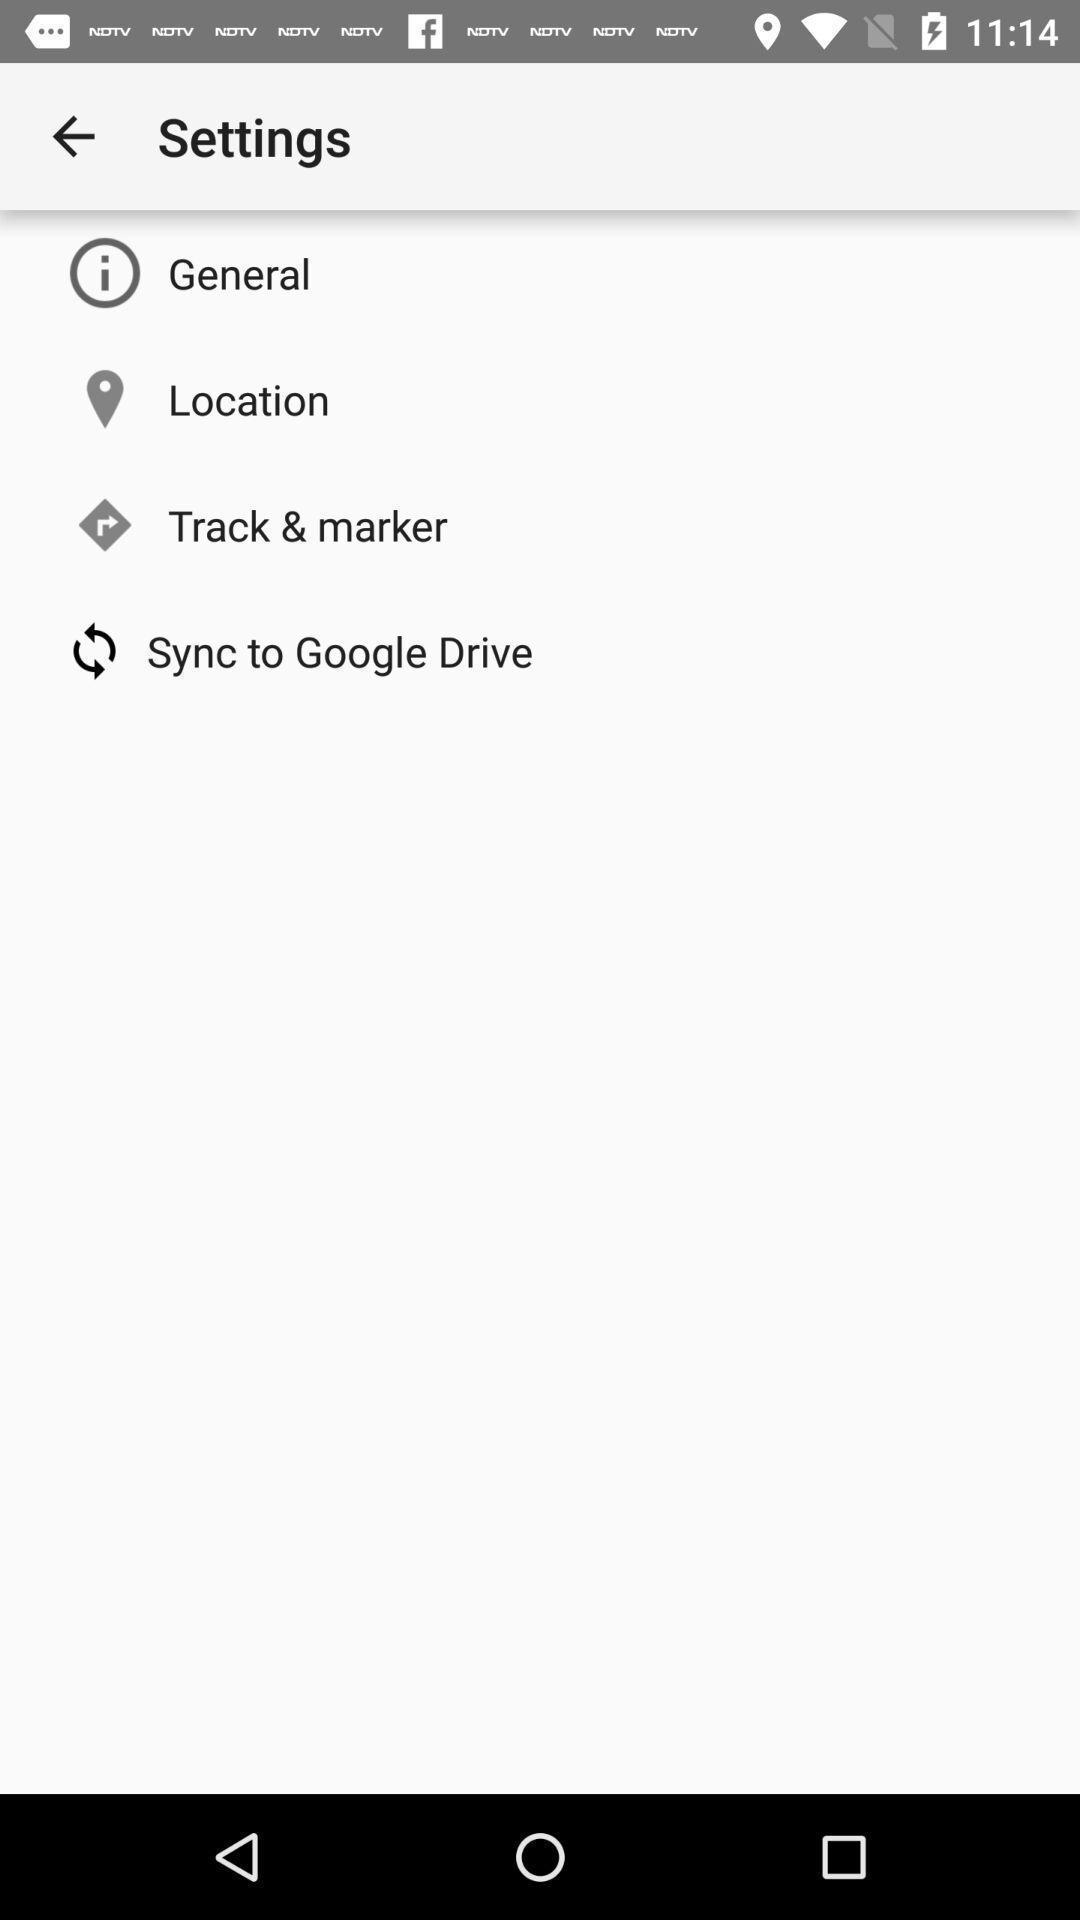Describe the key features of this screenshot. Various settings. 